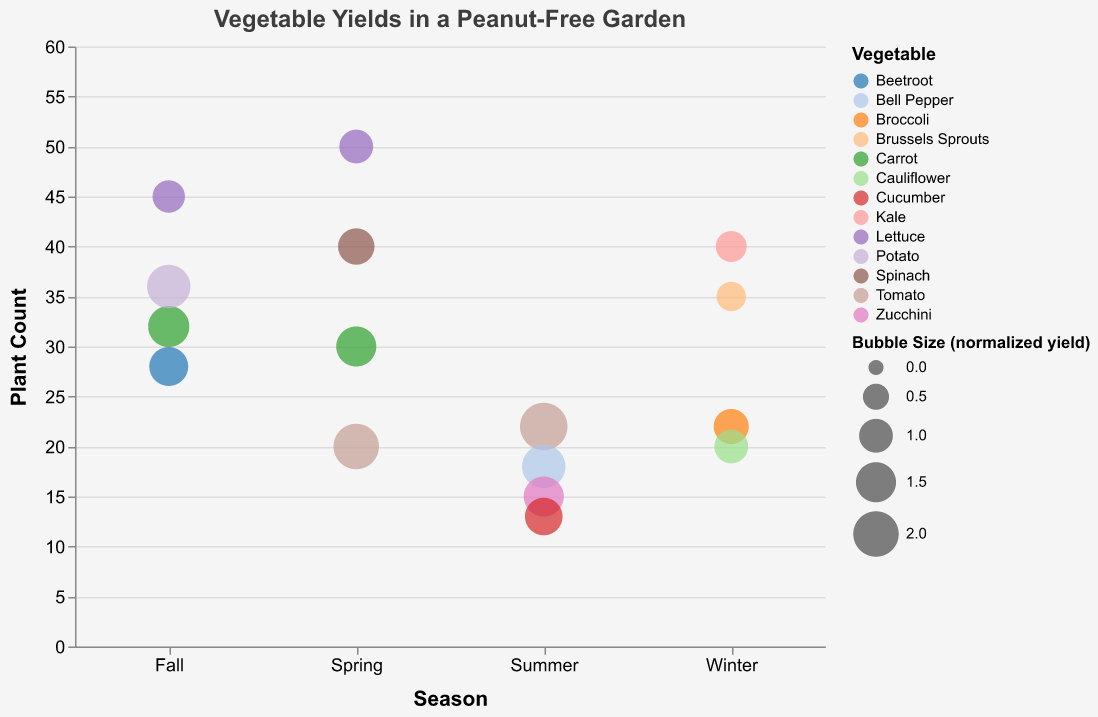What's the title of the chart? The title is displayed at the top of the chart and it reads "Vegetable Yields in a Peanut-Free Garden".
Answer: Vegetable Yields in a Peanut-Free Garden In which season is the plant count for Tomatoes the largest? To determine the plant count for Tomatoes in each season, we look at the bubble sizes and their positions on the x-axis labeled with different seasons. The largest count for Tomatoes is in Summer.
Answer: Summer Which vegetable has the highest yield in Spring and what is the yield? To find the highest yield in Spring, look at the yields associated with each vegetable in Spring. The vegetable with the highest yield in Spring is Tomato with a yield of 200 kg.
Answer: Tomato, 200 kg What is the total plant count for all vegetables in Winter? Add the plant counts for Kale, Brussels Sprouts, Broccoli, and Cauliflower in Winter: 40 + 35 + 22 + 20.
Answer: 117 Which vegetable appears to be an outlier in the total yield during Winter? By comparing the bubble sizes and their corresponding yields, the vegetable with the largest bubble size indicating the highest yield in Winter is Broccoli with 110 kg.
Answer: Broccoli Compare the yield of Carrots between Spring and Fall. Which has a higher yield and by how much? Compare the yields: Carrot in Spring is 150 kg and in Fall is 160 kg. The fall yield is higher by 10 kg.
Answer: Fall, 10 kg What are the vegetables grown in Summer that have a higher bubble size than 2.0 (normalized yield)? In Summer, the vegetables and their bubble sizes are: Tomato (2.2), Bell Pepper (1.8), Zucchini (1.5), and Cucumber (1.3). Only Tomato has a bubble size higher than 2.0.
Answer: Tomato Which vegetable has the highest normalized yield in the entire dataset and in which season is it grown? Checking the normalized yield for all vegetables across all seasons, the highest normalized yield is 2.2 for Tomato in Summer.
Answer: Tomato in Summer What is the relationship between the bubble size and the yield of the vegetables in Spring? The bubble size represents the normalized yield. Larger bubbles correlate with higher yields. For instance, Tomato has the highest yield (200 kg) and the largest bubble size (2.0).
Answer: Larger bubbles have higher yields Which season sees the highest diversity of vegetable types based on the number of different vegetables grown? Count the different vegetables in each season: Spring (4 types), Summer (4 types), Fall (4 types), Winter (4 types). All seasons have the same diversity in terms of vegetable types.
Answer: All seasons have the same diversity 